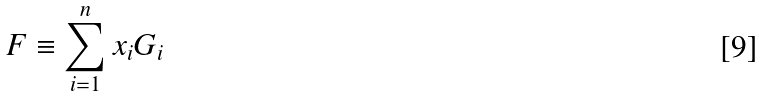<formula> <loc_0><loc_0><loc_500><loc_500>F \equiv \sum _ { i = 1 } ^ { n } x _ { i } G _ { i }</formula> 